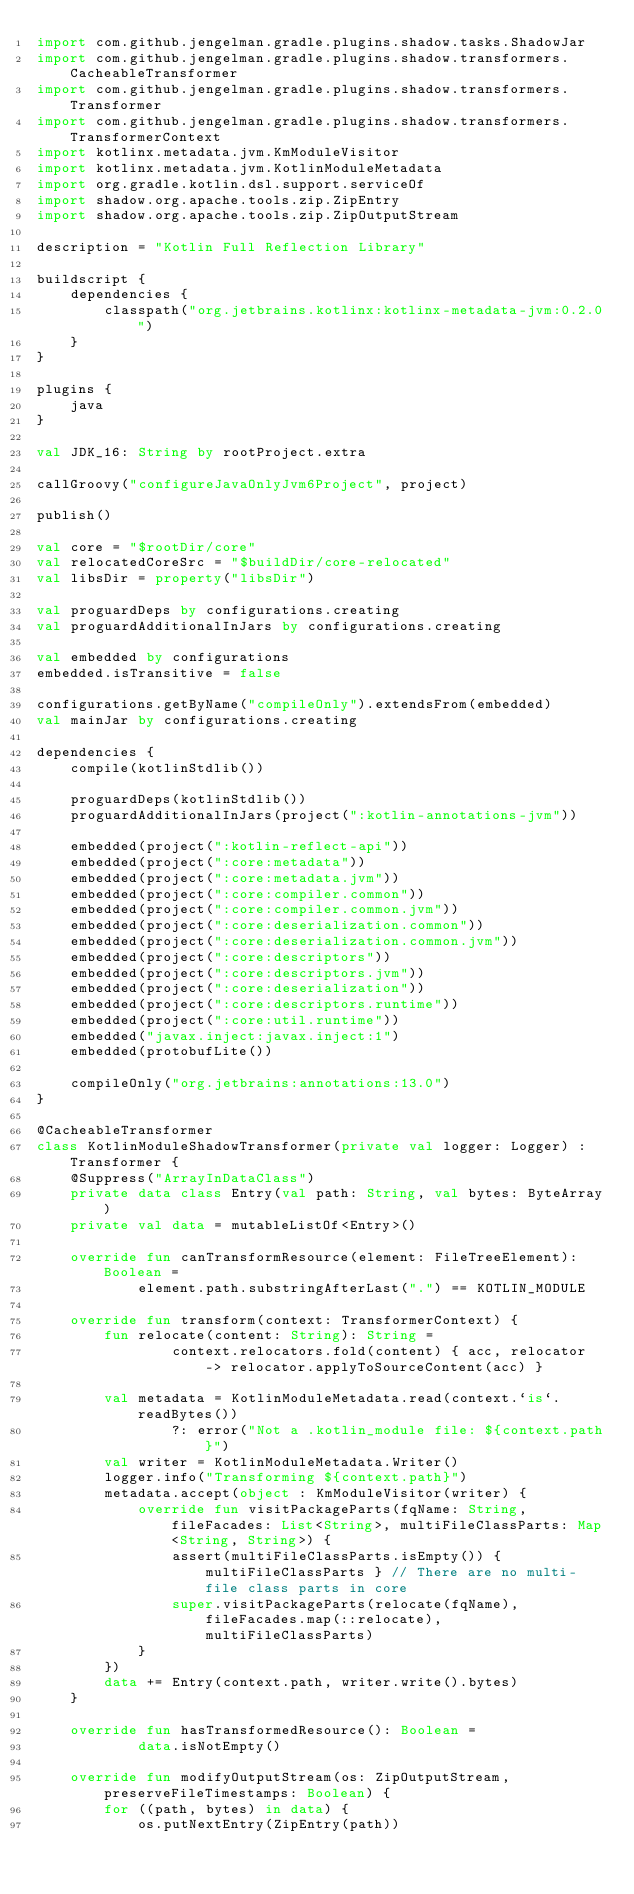<code> <loc_0><loc_0><loc_500><loc_500><_Kotlin_>import com.github.jengelman.gradle.plugins.shadow.tasks.ShadowJar
import com.github.jengelman.gradle.plugins.shadow.transformers.CacheableTransformer
import com.github.jengelman.gradle.plugins.shadow.transformers.Transformer
import com.github.jengelman.gradle.plugins.shadow.transformers.TransformerContext
import kotlinx.metadata.jvm.KmModuleVisitor
import kotlinx.metadata.jvm.KotlinModuleMetadata
import org.gradle.kotlin.dsl.support.serviceOf
import shadow.org.apache.tools.zip.ZipEntry
import shadow.org.apache.tools.zip.ZipOutputStream

description = "Kotlin Full Reflection Library"

buildscript {
    dependencies {
        classpath("org.jetbrains.kotlinx:kotlinx-metadata-jvm:0.2.0")
    }
}

plugins {
    java
}

val JDK_16: String by rootProject.extra

callGroovy("configureJavaOnlyJvm6Project", project)

publish()

val core = "$rootDir/core"
val relocatedCoreSrc = "$buildDir/core-relocated"
val libsDir = property("libsDir")

val proguardDeps by configurations.creating
val proguardAdditionalInJars by configurations.creating

val embedded by configurations
embedded.isTransitive = false

configurations.getByName("compileOnly").extendsFrom(embedded)
val mainJar by configurations.creating

dependencies {
    compile(kotlinStdlib())

    proguardDeps(kotlinStdlib())
    proguardAdditionalInJars(project(":kotlin-annotations-jvm"))

    embedded(project(":kotlin-reflect-api"))
    embedded(project(":core:metadata"))
    embedded(project(":core:metadata.jvm"))
    embedded(project(":core:compiler.common"))
    embedded(project(":core:compiler.common.jvm"))
    embedded(project(":core:deserialization.common"))
    embedded(project(":core:deserialization.common.jvm"))
    embedded(project(":core:descriptors"))
    embedded(project(":core:descriptors.jvm"))
    embedded(project(":core:deserialization"))
    embedded(project(":core:descriptors.runtime"))
    embedded(project(":core:util.runtime"))
    embedded("javax.inject:javax.inject:1")
    embedded(protobufLite())

    compileOnly("org.jetbrains:annotations:13.0")
}

@CacheableTransformer
class KotlinModuleShadowTransformer(private val logger: Logger) : Transformer {
    @Suppress("ArrayInDataClass")
    private data class Entry(val path: String, val bytes: ByteArray)
    private val data = mutableListOf<Entry>()

    override fun canTransformResource(element: FileTreeElement): Boolean =
            element.path.substringAfterLast(".") == KOTLIN_MODULE

    override fun transform(context: TransformerContext) {
        fun relocate(content: String): String =
                context.relocators.fold(content) { acc, relocator -> relocator.applyToSourceContent(acc) }

        val metadata = KotlinModuleMetadata.read(context.`is`.readBytes())
                ?: error("Not a .kotlin_module file: ${context.path}")
        val writer = KotlinModuleMetadata.Writer()
        logger.info("Transforming ${context.path}")
        metadata.accept(object : KmModuleVisitor(writer) {
            override fun visitPackageParts(fqName: String, fileFacades: List<String>, multiFileClassParts: Map<String, String>) {
                assert(multiFileClassParts.isEmpty()) { multiFileClassParts } // There are no multi-file class parts in core
                super.visitPackageParts(relocate(fqName), fileFacades.map(::relocate), multiFileClassParts)
            }
        })
        data += Entry(context.path, writer.write().bytes)
    }

    override fun hasTransformedResource(): Boolean =
            data.isNotEmpty()

    override fun modifyOutputStream(os: ZipOutputStream, preserveFileTimestamps: Boolean) {
        for ((path, bytes) in data) {
            os.putNextEntry(ZipEntry(path))</code> 